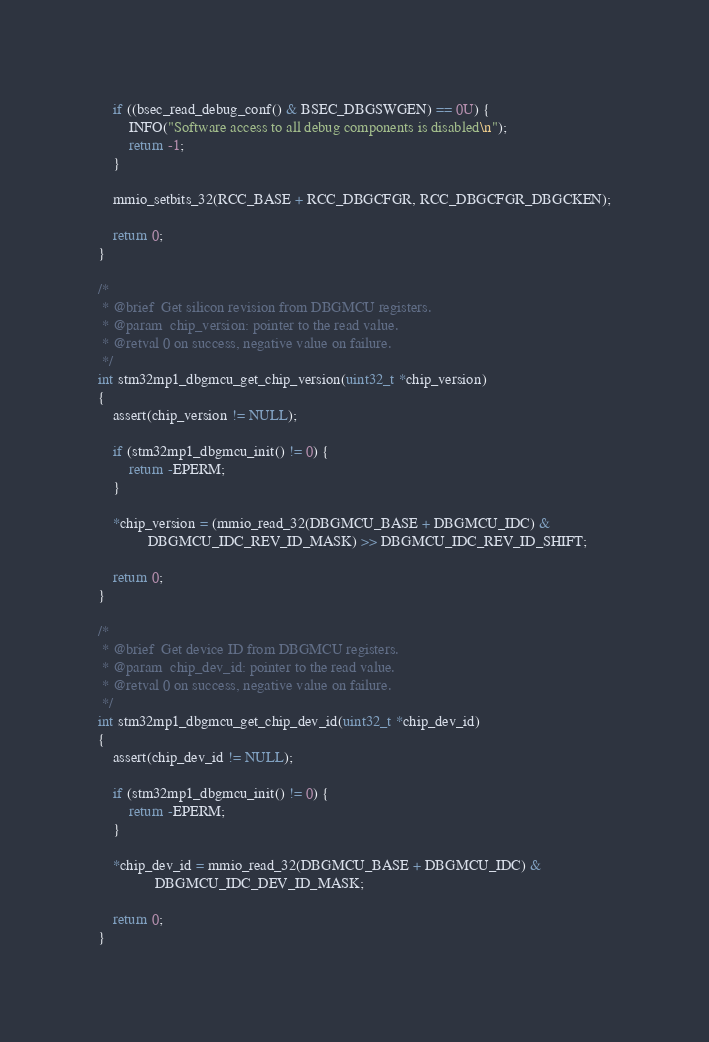Convert code to text. <code><loc_0><loc_0><loc_500><loc_500><_C_>	if ((bsec_read_debug_conf() & BSEC_DBGSWGEN) == 0U) {
		INFO("Software access to all debug components is disabled\n");
		return -1;
	}

	mmio_setbits_32(RCC_BASE + RCC_DBGCFGR, RCC_DBGCFGR_DBGCKEN);

	return 0;
}

/*
 * @brief  Get silicon revision from DBGMCU registers.
 * @param  chip_version: pointer to the read value.
 * @retval 0 on success, negative value on failure.
 */
int stm32mp1_dbgmcu_get_chip_version(uint32_t *chip_version)
{
	assert(chip_version != NULL);

	if (stm32mp1_dbgmcu_init() != 0) {
		return -EPERM;
	}

	*chip_version = (mmio_read_32(DBGMCU_BASE + DBGMCU_IDC) &
			 DBGMCU_IDC_REV_ID_MASK) >> DBGMCU_IDC_REV_ID_SHIFT;

	return 0;
}

/*
 * @brief  Get device ID from DBGMCU registers.
 * @param  chip_dev_id: pointer to the read value.
 * @retval 0 on success, negative value on failure.
 */
int stm32mp1_dbgmcu_get_chip_dev_id(uint32_t *chip_dev_id)
{
	assert(chip_dev_id != NULL);

	if (stm32mp1_dbgmcu_init() != 0) {
		return -EPERM;
	}

	*chip_dev_id = mmio_read_32(DBGMCU_BASE + DBGMCU_IDC) &
		       DBGMCU_IDC_DEV_ID_MASK;

	return 0;
}
</code> 